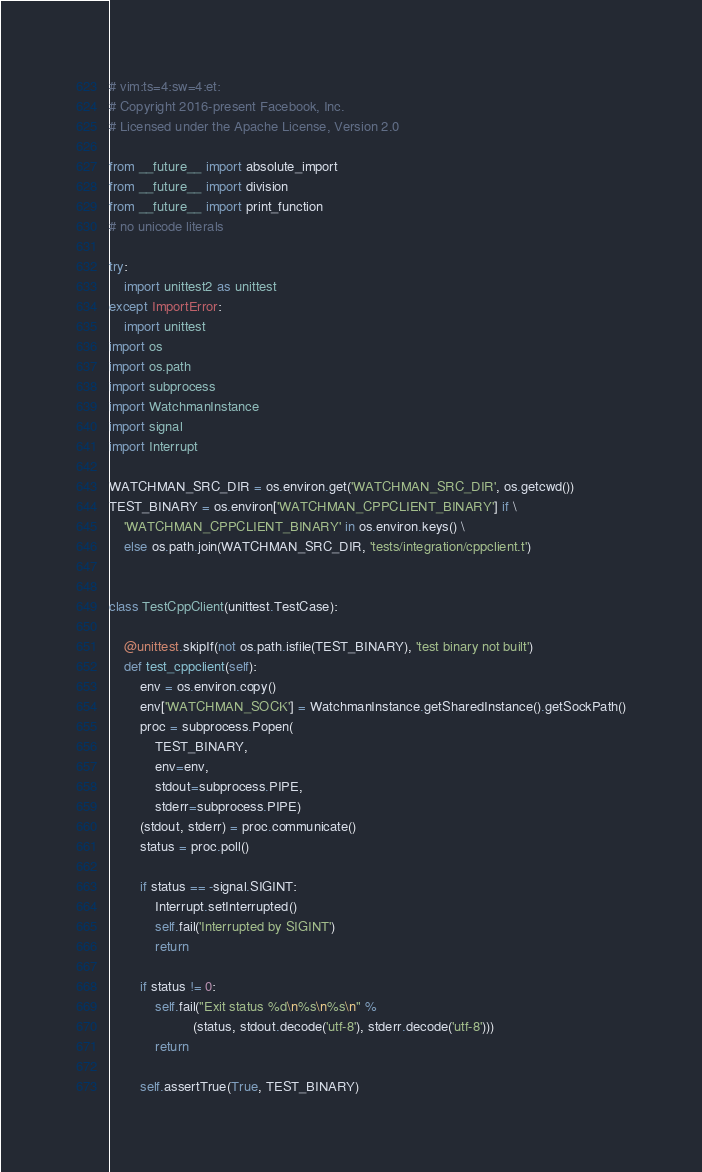<code> <loc_0><loc_0><loc_500><loc_500><_Python_># vim:ts=4:sw=4:et:
# Copyright 2016-present Facebook, Inc.
# Licensed under the Apache License, Version 2.0

from __future__ import absolute_import
from __future__ import division
from __future__ import print_function
# no unicode literals

try:
    import unittest2 as unittest
except ImportError:
    import unittest
import os
import os.path
import subprocess
import WatchmanInstance
import signal
import Interrupt

WATCHMAN_SRC_DIR = os.environ.get('WATCHMAN_SRC_DIR', os.getcwd())
TEST_BINARY = os.environ['WATCHMAN_CPPCLIENT_BINARY'] if \
    'WATCHMAN_CPPCLIENT_BINARY' in os.environ.keys() \
    else os.path.join(WATCHMAN_SRC_DIR, 'tests/integration/cppclient.t')


class TestCppClient(unittest.TestCase):

    @unittest.skipIf(not os.path.isfile(TEST_BINARY), 'test binary not built')
    def test_cppclient(self):
        env = os.environ.copy()
        env['WATCHMAN_SOCK'] = WatchmanInstance.getSharedInstance().getSockPath()
        proc = subprocess.Popen(
            TEST_BINARY,
            env=env,
            stdout=subprocess.PIPE,
            stderr=subprocess.PIPE)
        (stdout, stderr) = proc.communicate()
        status = proc.poll()

        if status == -signal.SIGINT:
            Interrupt.setInterrupted()
            self.fail('Interrupted by SIGINT')
            return

        if status != 0:
            self.fail("Exit status %d\n%s\n%s\n" %
                      (status, stdout.decode('utf-8'), stderr.decode('utf-8')))
            return

        self.assertTrue(True, TEST_BINARY)
</code> 